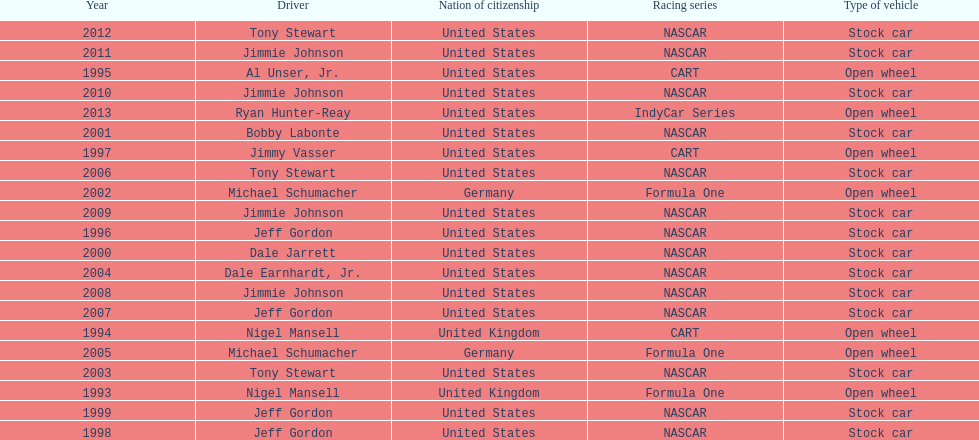Which drivers have won the best driver espy award? Nigel Mansell, Nigel Mansell, Al Unser, Jr., Jeff Gordon, Jimmy Vasser, Jeff Gordon, Jeff Gordon, Dale Jarrett, Bobby Labonte, Michael Schumacher, Tony Stewart, Dale Earnhardt, Jr., Michael Schumacher, Tony Stewart, Jeff Gordon, Jimmie Johnson, Jimmie Johnson, Jimmie Johnson, Jimmie Johnson, Tony Stewart, Ryan Hunter-Reay. Of these, which only appear once? Al Unser, Jr., Jimmy Vasser, Dale Jarrett, Dale Earnhardt, Jr., Ryan Hunter-Reay. Which of these are from the cart racing series? Al Unser, Jr., Jimmy Vasser. Of these, which received their award first? Al Unser, Jr. 